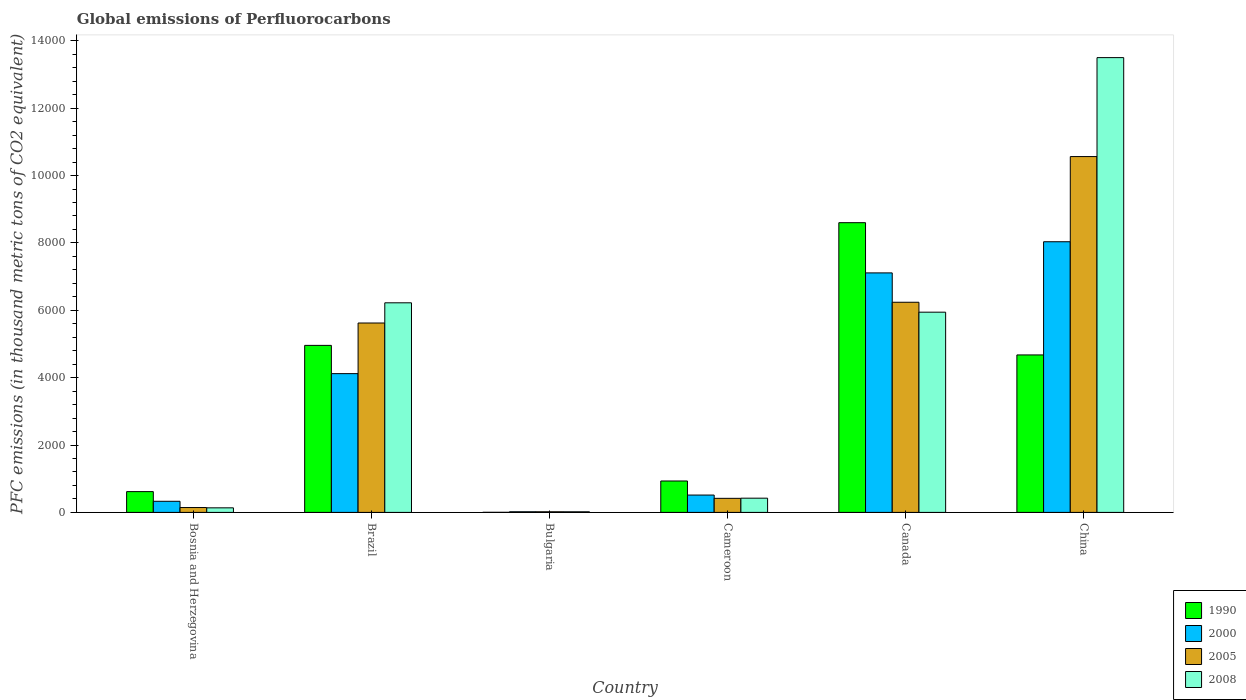Are the number of bars per tick equal to the number of legend labels?
Your answer should be very brief. Yes. Are the number of bars on each tick of the X-axis equal?
Your response must be concise. Yes. What is the label of the 4th group of bars from the left?
Your answer should be very brief. Cameroon. In how many cases, is the number of bars for a given country not equal to the number of legend labels?
Your answer should be compact. 0. What is the global emissions of Perfluorocarbons in 1990 in Bulgaria?
Give a very brief answer. 2.2. Across all countries, what is the maximum global emissions of Perfluorocarbons in 2000?
Make the answer very short. 8034.4. In which country was the global emissions of Perfluorocarbons in 2005 maximum?
Your response must be concise. China. In which country was the global emissions of Perfluorocarbons in 2005 minimum?
Your response must be concise. Bulgaria. What is the total global emissions of Perfluorocarbons in 2005 in the graph?
Make the answer very short. 2.30e+04. What is the difference between the global emissions of Perfluorocarbons in 2008 in Brazil and that in Bulgaria?
Your response must be concise. 6203.6. What is the difference between the global emissions of Perfluorocarbons in 2000 in China and the global emissions of Perfluorocarbons in 2005 in Bosnia and Herzegovina?
Keep it short and to the point. 7890. What is the average global emissions of Perfluorocarbons in 1990 per country?
Offer a terse response. 3297.35. What is the difference between the global emissions of Perfluorocarbons of/in 2005 and global emissions of Perfluorocarbons of/in 1990 in Bosnia and Herzegovina?
Make the answer very short. -472.3. In how many countries, is the global emissions of Perfluorocarbons in 2008 greater than 5200 thousand metric tons?
Provide a short and direct response. 3. What is the ratio of the global emissions of Perfluorocarbons in 2005 in Bulgaria to that in Canada?
Provide a succinct answer. 0. Is the difference between the global emissions of Perfluorocarbons in 2005 in Bosnia and Herzegovina and China greater than the difference between the global emissions of Perfluorocarbons in 1990 in Bosnia and Herzegovina and China?
Keep it short and to the point. No. What is the difference between the highest and the second highest global emissions of Perfluorocarbons in 2005?
Give a very brief answer. 4940.7. What is the difference between the highest and the lowest global emissions of Perfluorocarbons in 1990?
Keep it short and to the point. 8598.1. In how many countries, is the global emissions of Perfluorocarbons in 2005 greater than the average global emissions of Perfluorocarbons in 2005 taken over all countries?
Offer a very short reply. 3. Is it the case that in every country, the sum of the global emissions of Perfluorocarbons in 2008 and global emissions of Perfluorocarbons in 2005 is greater than the sum of global emissions of Perfluorocarbons in 1990 and global emissions of Perfluorocarbons in 2000?
Your response must be concise. No. What does the 1st bar from the right in Cameroon represents?
Keep it short and to the point. 2008. How many bars are there?
Offer a terse response. 24. Are all the bars in the graph horizontal?
Offer a very short reply. No. What is the difference between two consecutive major ticks on the Y-axis?
Your answer should be very brief. 2000. Are the values on the major ticks of Y-axis written in scientific E-notation?
Your answer should be very brief. No. Does the graph contain any zero values?
Your answer should be compact. No. Where does the legend appear in the graph?
Offer a very short reply. Bottom right. How are the legend labels stacked?
Offer a terse response. Vertical. What is the title of the graph?
Give a very brief answer. Global emissions of Perfluorocarbons. What is the label or title of the Y-axis?
Offer a terse response. PFC emissions (in thousand metric tons of CO2 equivalent). What is the PFC emissions (in thousand metric tons of CO2 equivalent) in 1990 in Bosnia and Herzegovina?
Your answer should be compact. 616.7. What is the PFC emissions (in thousand metric tons of CO2 equivalent) of 2000 in Bosnia and Herzegovina?
Provide a succinct answer. 329.9. What is the PFC emissions (in thousand metric tons of CO2 equivalent) of 2005 in Bosnia and Herzegovina?
Your answer should be compact. 144.4. What is the PFC emissions (in thousand metric tons of CO2 equivalent) in 2008 in Bosnia and Herzegovina?
Keep it short and to the point. 135.6. What is the PFC emissions (in thousand metric tons of CO2 equivalent) of 1990 in Brazil?
Ensure brevity in your answer.  4958.1. What is the PFC emissions (in thousand metric tons of CO2 equivalent) in 2000 in Brazil?
Ensure brevity in your answer.  4119.1. What is the PFC emissions (in thousand metric tons of CO2 equivalent) in 2005 in Brazil?
Your answer should be compact. 5622.1. What is the PFC emissions (in thousand metric tons of CO2 equivalent) of 2008 in Brazil?
Provide a succinct answer. 6221.8. What is the PFC emissions (in thousand metric tons of CO2 equivalent) of 1990 in Bulgaria?
Your answer should be compact. 2.2. What is the PFC emissions (in thousand metric tons of CO2 equivalent) in 2008 in Bulgaria?
Provide a short and direct response. 18.2. What is the PFC emissions (in thousand metric tons of CO2 equivalent) in 1990 in Cameroon?
Your answer should be compact. 932.3. What is the PFC emissions (in thousand metric tons of CO2 equivalent) in 2000 in Cameroon?
Make the answer very short. 514.7. What is the PFC emissions (in thousand metric tons of CO2 equivalent) in 2005 in Cameroon?
Offer a very short reply. 417.5. What is the PFC emissions (in thousand metric tons of CO2 equivalent) of 2008 in Cameroon?
Keep it short and to the point. 422.1. What is the PFC emissions (in thousand metric tons of CO2 equivalent) of 1990 in Canada?
Provide a succinct answer. 8600.3. What is the PFC emissions (in thousand metric tons of CO2 equivalent) of 2000 in Canada?
Provide a succinct answer. 7109.9. What is the PFC emissions (in thousand metric tons of CO2 equivalent) of 2005 in Canada?
Make the answer very short. 6238. What is the PFC emissions (in thousand metric tons of CO2 equivalent) of 2008 in Canada?
Provide a succinct answer. 5943.7. What is the PFC emissions (in thousand metric tons of CO2 equivalent) of 1990 in China?
Your answer should be very brief. 4674.5. What is the PFC emissions (in thousand metric tons of CO2 equivalent) of 2000 in China?
Give a very brief answer. 8034.4. What is the PFC emissions (in thousand metric tons of CO2 equivalent) of 2005 in China?
Your response must be concise. 1.06e+04. What is the PFC emissions (in thousand metric tons of CO2 equivalent) in 2008 in China?
Provide a succinct answer. 1.35e+04. Across all countries, what is the maximum PFC emissions (in thousand metric tons of CO2 equivalent) in 1990?
Your response must be concise. 8600.3. Across all countries, what is the maximum PFC emissions (in thousand metric tons of CO2 equivalent) of 2000?
Give a very brief answer. 8034.4. Across all countries, what is the maximum PFC emissions (in thousand metric tons of CO2 equivalent) of 2005?
Your answer should be very brief. 1.06e+04. Across all countries, what is the maximum PFC emissions (in thousand metric tons of CO2 equivalent) in 2008?
Give a very brief answer. 1.35e+04. Across all countries, what is the minimum PFC emissions (in thousand metric tons of CO2 equivalent) in 1990?
Ensure brevity in your answer.  2.2. Across all countries, what is the minimum PFC emissions (in thousand metric tons of CO2 equivalent) in 2008?
Your answer should be very brief. 18.2. What is the total PFC emissions (in thousand metric tons of CO2 equivalent) in 1990 in the graph?
Your answer should be compact. 1.98e+04. What is the total PFC emissions (in thousand metric tons of CO2 equivalent) in 2000 in the graph?
Make the answer very short. 2.01e+04. What is the total PFC emissions (in thousand metric tons of CO2 equivalent) in 2005 in the graph?
Your answer should be very brief. 2.30e+04. What is the total PFC emissions (in thousand metric tons of CO2 equivalent) of 2008 in the graph?
Give a very brief answer. 2.62e+04. What is the difference between the PFC emissions (in thousand metric tons of CO2 equivalent) in 1990 in Bosnia and Herzegovina and that in Brazil?
Ensure brevity in your answer.  -4341.4. What is the difference between the PFC emissions (in thousand metric tons of CO2 equivalent) of 2000 in Bosnia and Herzegovina and that in Brazil?
Your answer should be compact. -3789.2. What is the difference between the PFC emissions (in thousand metric tons of CO2 equivalent) of 2005 in Bosnia and Herzegovina and that in Brazil?
Ensure brevity in your answer.  -5477.7. What is the difference between the PFC emissions (in thousand metric tons of CO2 equivalent) of 2008 in Bosnia and Herzegovina and that in Brazil?
Your response must be concise. -6086.2. What is the difference between the PFC emissions (in thousand metric tons of CO2 equivalent) in 1990 in Bosnia and Herzegovina and that in Bulgaria?
Ensure brevity in your answer.  614.5. What is the difference between the PFC emissions (in thousand metric tons of CO2 equivalent) of 2000 in Bosnia and Herzegovina and that in Bulgaria?
Your answer should be compact. 310.8. What is the difference between the PFC emissions (in thousand metric tons of CO2 equivalent) in 2005 in Bosnia and Herzegovina and that in Bulgaria?
Give a very brief answer. 125.9. What is the difference between the PFC emissions (in thousand metric tons of CO2 equivalent) of 2008 in Bosnia and Herzegovina and that in Bulgaria?
Provide a succinct answer. 117.4. What is the difference between the PFC emissions (in thousand metric tons of CO2 equivalent) in 1990 in Bosnia and Herzegovina and that in Cameroon?
Keep it short and to the point. -315.6. What is the difference between the PFC emissions (in thousand metric tons of CO2 equivalent) of 2000 in Bosnia and Herzegovina and that in Cameroon?
Offer a terse response. -184.8. What is the difference between the PFC emissions (in thousand metric tons of CO2 equivalent) of 2005 in Bosnia and Herzegovina and that in Cameroon?
Provide a succinct answer. -273.1. What is the difference between the PFC emissions (in thousand metric tons of CO2 equivalent) in 2008 in Bosnia and Herzegovina and that in Cameroon?
Provide a succinct answer. -286.5. What is the difference between the PFC emissions (in thousand metric tons of CO2 equivalent) of 1990 in Bosnia and Herzegovina and that in Canada?
Give a very brief answer. -7983.6. What is the difference between the PFC emissions (in thousand metric tons of CO2 equivalent) of 2000 in Bosnia and Herzegovina and that in Canada?
Offer a very short reply. -6780. What is the difference between the PFC emissions (in thousand metric tons of CO2 equivalent) in 2005 in Bosnia and Herzegovina and that in Canada?
Ensure brevity in your answer.  -6093.6. What is the difference between the PFC emissions (in thousand metric tons of CO2 equivalent) in 2008 in Bosnia and Herzegovina and that in Canada?
Ensure brevity in your answer.  -5808.1. What is the difference between the PFC emissions (in thousand metric tons of CO2 equivalent) of 1990 in Bosnia and Herzegovina and that in China?
Offer a terse response. -4057.8. What is the difference between the PFC emissions (in thousand metric tons of CO2 equivalent) in 2000 in Bosnia and Herzegovina and that in China?
Offer a very short reply. -7704.5. What is the difference between the PFC emissions (in thousand metric tons of CO2 equivalent) in 2005 in Bosnia and Herzegovina and that in China?
Give a very brief answer. -1.04e+04. What is the difference between the PFC emissions (in thousand metric tons of CO2 equivalent) in 2008 in Bosnia and Herzegovina and that in China?
Make the answer very short. -1.34e+04. What is the difference between the PFC emissions (in thousand metric tons of CO2 equivalent) of 1990 in Brazil and that in Bulgaria?
Your response must be concise. 4955.9. What is the difference between the PFC emissions (in thousand metric tons of CO2 equivalent) in 2000 in Brazil and that in Bulgaria?
Give a very brief answer. 4100. What is the difference between the PFC emissions (in thousand metric tons of CO2 equivalent) in 2005 in Brazil and that in Bulgaria?
Offer a very short reply. 5603.6. What is the difference between the PFC emissions (in thousand metric tons of CO2 equivalent) of 2008 in Brazil and that in Bulgaria?
Provide a succinct answer. 6203.6. What is the difference between the PFC emissions (in thousand metric tons of CO2 equivalent) in 1990 in Brazil and that in Cameroon?
Offer a very short reply. 4025.8. What is the difference between the PFC emissions (in thousand metric tons of CO2 equivalent) of 2000 in Brazil and that in Cameroon?
Your answer should be very brief. 3604.4. What is the difference between the PFC emissions (in thousand metric tons of CO2 equivalent) of 2005 in Brazil and that in Cameroon?
Your answer should be compact. 5204.6. What is the difference between the PFC emissions (in thousand metric tons of CO2 equivalent) of 2008 in Brazil and that in Cameroon?
Ensure brevity in your answer.  5799.7. What is the difference between the PFC emissions (in thousand metric tons of CO2 equivalent) of 1990 in Brazil and that in Canada?
Offer a terse response. -3642.2. What is the difference between the PFC emissions (in thousand metric tons of CO2 equivalent) of 2000 in Brazil and that in Canada?
Your response must be concise. -2990.8. What is the difference between the PFC emissions (in thousand metric tons of CO2 equivalent) of 2005 in Brazil and that in Canada?
Ensure brevity in your answer.  -615.9. What is the difference between the PFC emissions (in thousand metric tons of CO2 equivalent) of 2008 in Brazil and that in Canada?
Provide a short and direct response. 278.1. What is the difference between the PFC emissions (in thousand metric tons of CO2 equivalent) in 1990 in Brazil and that in China?
Offer a very short reply. 283.6. What is the difference between the PFC emissions (in thousand metric tons of CO2 equivalent) of 2000 in Brazil and that in China?
Your response must be concise. -3915.3. What is the difference between the PFC emissions (in thousand metric tons of CO2 equivalent) of 2005 in Brazil and that in China?
Provide a succinct answer. -4940.7. What is the difference between the PFC emissions (in thousand metric tons of CO2 equivalent) of 2008 in Brazil and that in China?
Your answer should be compact. -7278.8. What is the difference between the PFC emissions (in thousand metric tons of CO2 equivalent) in 1990 in Bulgaria and that in Cameroon?
Keep it short and to the point. -930.1. What is the difference between the PFC emissions (in thousand metric tons of CO2 equivalent) of 2000 in Bulgaria and that in Cameroon?
Provide a short and direct response. -495.6. What is the difference between the PFC emissions (in thousand metric tons of CO2 equivalent) of 2005 in Bulgaria and that in Cameroon?
Make the answer very short. -399. What is the difference between the PFC emissions (in thousand metric tons of CO2 equivalent) in 2008 in Bulgaria and that in Cameroon?
Your response must be concise. -403.9. What is the difference between the PFC emissions (in thousand metric tons of CO2 equivalent) in 1990 in Bulgaria and that in Canada?
Provide a short and direct response. -8598.1. What is the difference between the PFC emissions (in thousand metric tons of CO2 equivalent) of 2000 in Bulgaria and that in Canada?
Provide a succinct answer. -7090.8. What is the difference between the PFC emissions (in thousand metric tons of CO2 equivalent) in 2005 in Bulgaria and that in Canada?
Give a very brief answer. -6219.5. What is the difference between the PFC emissions (in thousand metric tons of CO2 equivalent) of 2008 in Bulgaria and that in Canada?
Ensure brevity in your answer.  -5925.5. What is the difference between the PFC emissions (in thousand metric tons of CO2 equivalent) in 1990 in Bulgaria and that in China?
Your answer should be compact. -4672.3. What is the difference between the PFC emissions (in thousand metric tons of CO2 equivalent) of 2000 in Bulgaria and that in China?
Provide a short and direct response. -8015.3. What is the difference between the PFC emissions (in thousand metric tons of CO2 equivalent) in 2005 in Bulgaria and that in China?
Ensure brevity in your answer.  -1.05e+04. What is the difference between the PFC emissions (in thousand metric tons of CO2 equivalent) of 2008 in Bulgaria and that in China?
Offer a very short reply. -1.35e+04. What is the difference between the PFC emissions (in thousand metric tons of CO2 equivalent) in 1990 in Cameroon and that in Canada?
Your answer should be compact. -7668. What is the difference between the PFC emissions (in thousand metric tons of CO2 equivalent) of 2000 in Cameroon and that in Canada?
Offer a terse response. -6595.2. What is the difference between the PFC emissions (in thousand metric tons of CO2 equivalent) in 2005 in Cameroon and that in Canada?
Your response must be concise. -5820.5. What is the difference between the PFC emissions (in thousand metric tons of CO2 equivalent) of 2008 in Cameroon and that in Canada?
Offer a very short reply. -5521.6. What is the difference between the PFC emissions (in thousand metric tons of CO2 equivalent) in 1990 in Cameroon and that in China?
Offer a very short reply. -3742.2. What is the difference between the PFC emissions (in thousand metric tons of CO2 equivalent) of 2000 in Cameroon and that in China?
Your response must be concise. -7519.7. What is the difference between the PFC emissions (in thousand metric tons of CO2 equivalent) of 2005 in Cameroon and that in China?
Your response must be concise. -1.01e+04. What is the difference between the PFC emissions (in thousand metric tons of CO2 equivalent) in 2008 in Cameroon and that in China?
Your response must be concise. -1.31e+04. What is the difference between the PFC emissions (in thousand metric tons of CO2 equivalent) of 1990 in Canada and that in China?
Ensure brevity in your answer.  3925.8. What is the difference between the PFC emissions (in thousand metric tons of CO2 equivalent) in 2000 in Canada and that in China?
Keep it short and to the point. -924.5. What is the difference between the PFC emissions (in thousand metric tons of CO2 equivalent) of 2005 in Canada and that in China?
Ensure brevity in your answer.  -4324.8. What is the difference between the PFC emissions (in thousand metric tons of CO2 equivalent) in 2008 in Canada and that in China?
Your answer should be compact. -7556.9. What is the difference between the PFC emissions (in thousand metric tons of CO2 equivalent) of 1990 in Bosnia and Herzegovina and the PFC emissions (in thousand metric tons of CO2 equivalent) of 2000 in Brazil?
Make the answer very short. -3502.4. What is the difference between the PFC emissions (in thousand metric tons of CO2 equivalent) in 1990 in Bosnia and Herzegovina and the PFC emissions (in thousand metric tons of CO2 equivalent) in 2005 in Brazil?
Provide a succinct answer. -5005.4. What is the difference between the PFC emissions (in thousand metric tons of CO2 equivalent) in 1990 in Bosnia and Herzegovina and the PFC emissions (in thousand metric tons of CO2 equivalent) in 2008 in Brazil?
Provide a short and direct response. -5605.1. What is the difference between the PFC emissions (in thousand metric tons of CO2 equivalent) in 2000 in Bosnia and Herzegovina and the PFC emissions (in thousand metric tons of CO2 equivalent) in 2005 in Brazil?
Your answer should be very brief. -5292.2. What is the difference between the PFC emissions (in thousand metric tons of CO2 equivalent) of 2000 in Bosnia and Herzegovina and the PFC emissions (in thousand metric tons of CO2 equivalent) of 2008 in Brazil?
Ensure brevity in your answer.  -5891.9. What is the difference between the PFC emissions (in thousand metric tons of CO2 equivalent) of 2005 in Bosnia and Herzegovina and the PFC emissions (in thousand metric tons of CO2 equivalent) of 2008 in Brazil?
Ensure brevity in your answer.  -6077.4. What is the difference between the PFC emissions (in thousand metric tons of CO2 equivalent) in 1990 in Bosnia and Herzegovina and the PFC emissions (in thousand metric tons of CO2 equivalent) in 2000 in Bulgaria?
Your answer should be compact. 597.6. What is the difference between the PFC emissions (in thousand metric tons of CO2 equivalent) of 1990 in Bosnia and Herzegovina and the PFC emissions (in thousand metric tons of CO2 equivalent) of 2005 in Bulgaria?
Make the answer very short. 598.2. What is the difference between the PFC emissions (in thousand metric tons of CO2 equivalent) of 1990 in Bosnia and Herzegovina and the PFC emissions (in thousand metric tons of CO2 equivalent) of 2008 in Bulgaria?
Offer a very short reply. 598.5. What is the difference between the PFC emissions (in thousand metric tons of CO2 equivalent) of 2000 in Bosnia and Herzegovina and the PFC emissions (in thousand metric tons of CO2 equivalent) of 2005 in Bulgaria?
Your response must be concise. 311.4. What is the difference between the PFC emissions (in thousand metric tons of CO2 equivalent) in 2000 in Bosnia and Herzegovina and the PFC emissions (in thousand metric tons of CO2 equivalent) in 2008 in Bulgaria?
Give a very brief answer. 311.7. What is the difference between the PFC emissions (in thousand metric tons of CO2 equivalent) in 2005 in Bosnia and Herzegovina and the PFC emissions (in thousand metric tons of CO2 equivalent) in 2008 in Bulgaria?
Provide a short and direct response. 126.2. What is the difference between the PFC emissions (in thousand metric tons of CO2 equivalent) in 1990 in Bosnia and Herzegovina and the PFC emissions (in thousand metric tons of CO2 equivalent) in 2000 in Cameroon?
Make the answer very short. 102. What is the difference between the PFC emissions (in thousand metric tons of CO2 equivalent) of 1990 in Bosnia and Herzegovina and the PFC emissions (in thousand metric tons of CO2 equivalent) of 2005 in Cameroon?
Offer a very short reply. 199.2. What is the difference between the PFC emissions (in thousand metric tons of CO2 equivalent) in 1990 in Bosnia and Herzegovina and the PFC emissions (in thousand metric tons of CO2 equivalent) in 2008 in Cameroon?
Ensure brevity in your answer.  194.6. What is the difference between the PFC emissions (in thousand metric tons of CO2 equivalent) in 2000 in Bosnia and Herzegovina and the PFC emissions (in thousand metric tons of CO2 equivalent) in 2005 in Cameroon?
Offer a very short reply. -87.6. What is the difference between the PFC emissions (in thousand metric tons of CO2 equivalent) of 2000 in Bosnia and Herzegovina and the PFC emissions (in thousand metric tons of CO2 equivalent) of 2008 in Cameroon?
Make the answer very short. -92.2. What is the difference between the PFC emissions (in thousand metric tons of CO2 equivalent) in 2005 in Bosnia and Herzegovina and the PFC emissions (in thousand metric tons of CO2 equivalent) in 2008 in Cameroon?
Give a very brief answer. -277.7. What is the difference between the PFC emissions (in thousand metric tons of CO2 equivalent) in 1990 in Bosnia and Herzegovina and the PFC emissions (in thousand metric tons of CO2 equivalent) in 2000 in Canada?
Make the answer very short. -6493.2. What is the difference between the PFC emissions (in thousand metric tons of CO2 equivalent) in 1990 in Bosnia and Herzegovina and the PFC emissions (in thousand metric tons of CO2 equivalent) in 2005 in Canada?
Give a very brief answer. -5621.3. What is the difference between the PFC emissions (in thousand metric tons of CO2 equivalent) of 1990 in Bosnia and Herzegovina and the PFC emissions (in thousand metric tons of CO2 equivalent) of 2008 in Canada?
Ensure brevity in your answer.  -5327. What is the difference between the PFC emissions (in thousand metric tons of CO2 equivalent) in 2000 in Bosnia and Herzegovina and the PFC emissions (in thousand metric tons of CO2 equivalent) in 2005 in Canada?
Provide a short and direct response. -5908.1. What is the difference between the PFC emissions (in thousand metric tons of CO2 equivalent) in 2000 in Bosnia and Herzegovina and the PFC emissions (in thousand metric tons of CO2 equivalent) in 2008 in Canada?
Your answer should be very brief. -5613.8. What is the difference between the PFC emissions (in thousand metric tons of CO2 equivalent) in 2005 in Bosnia and Herzegovina and the PFC emissions (in thousand metric tons of CO2 equivalent) in 2008 in Canada?
Provide a short and direct response. -5799.3. What is the difference between the PFC emissions (in thousand metric tons of CO2 equivalent) in 1990 in Bosnia and Herzegovina and the PFC emissions (in thousand metric tons of CO2 equivalent) in 2000 in China?
Provide a succinct answer. -7417.7. What is the difference between the PFC emissions (in thousand metric tons of CO2 equivalent) in 1990 in Bosnia and Herzegovina and the PFC emissions (in thousand metric tons of CO2 equivalent) in 2005 in China?
Make the answer very short. -9946.1. What is the difference between the PFC emissions (in thousand metric tons of CO2 equivalent) in 1990 in Bosnia and Herzegovina and the PFC emissions (in thousand metric tons of CO2 equivalent) in 2008 in China?
Your answer should be compact. -1.29e+04. What is the difference between the PFC emissions (in thousand metric tons of CO2 equivalent) in 2000 in Bosnia and Herzegovina and the PFC emissions (in thousand metric tons of CO2 equivalent) in 2005 in China?
Give a very brief answer. -1.02e+04. What is the difference between the PFC emissions (in thousand metric tons of CO2 equivalent) in 2000 in Bosnia and Herzegovina and the PFC emissions (in thousand metric tons of CO2 equivalent) in 2008 in China?
Provide a succinct answer. -1.32e+04. What is the difference between the PFC emissions (in thousand metric tons of CO2 equivalent) of 2005 in Bosnia and Herzegovina and the PFC emissions (in thousand metric tons of CO2 equivalent) of 2008 in China?
Keep it short and to the point. -1.34e+04. What is the difference between the PFC emissions (in thousand metric tons of CO2 equivalent) in 1990 in Brazil and the PFC emissions (in thousand metric tons of CO2 equivalent) in 2000 in Bulgaria?
Ensure brevity in your answer.  4939. What is the difference between the PFC emissions (in thousand metric tons of CO2 equivalent) in 1990 in Brazil and the PFC emissions (in thousand metric tons of CO2 equivalent) in 2005 in Bulgaria?
Your response must be concise. 4939.6. What is the difference between the PFC emissions (in thousand metric tons of CO2 equivalent) in 1990 in Brazil and the PFC emissions (in thousand metric tons of CO2 equivalent) in 2008 in Bulgaria?
Ensure brevity in your answer.  4939.9. What is the difference between the PFC emissions (in thousand metric tons of CO2 equivalent) of 2000 in Brazil and the PFC emissions (in thousand metric tons of CO2 equivalent) of 2005 in Bulgaria?
Your response must be concise. 4100.6. What is the difference between the PFC emissions (in thousand metric tons of CO2 equivalent) of 2000 in Brazil and the PFC emissions (in thousand metric tons of CO2 equivalent) of 2008 in Bulgaria?
Offer a very short reply. 4100.9. What is the difference between the PFC emissions (in thousand metric tons of CO2 equivalent) in 2005 in Brazil and the PFC emissions (in thousand metric tons of CO2 equivalent) in 2008 in Bulgaria?
Keep it short and to the point. 5603.9. What is the difference between the PFC emissions (in thousand metric tons of CO2 equivalent) in 1990 in Brazil and the PFC emissions (in thousand metric tons of CO2 equivalent) in 2000 in Cameroon?
Offer a very short reply. 4443.4. What is the difference between the PFC emissions (in thousand metric tons of CO2 equivalent) in 1990 in Brazil and the PFC emissions (in thousand metric tons of CO2 equivalent) in 2005 in Cameroon?
Your response must be concise. 4540.6. What is the difference between the PFC emissions (in thousand metric tons of CO2 equivalent) in 1990 in Brazil and the PFC emissions (in thousand metric tons of CO2 equivalent) in 2008 in Cameroon?
Your answer should be compact. 4536. What is the difference between the PFC emissions (in thousand metric tons of CO2 equivalent) in 2000 in Brazil and the PFC emissions (in thousand metric tons of CO2 equivalent) in 2005 in Cameroon?
Provide a succinct answer. 3701.6. What is the difference between the PFC emissions (in thousand metric tons of CO2 equivalent) in 2000 in Brazil and the PFC emissions (in thousand metric tons of CO2 equivalent) in 2008 in Cameroon?
Give a very brief answer. 3697. What is the difference between the PFC emissions (in thousand metric tons of CO2 equivalent) in 2005 in Brazil and the PFC emissions (in thousand metric tons of CO2 equivalent) in 2008 in Cameroon?
Provide a succinct answer. 5200. What is the difference between the PFC emissions (in thousand metric tons of CO2 equivalent) in 1990 in Brazil and the PFC emissions (in thousand metric tons of CO2 equivalent) in 2000 in Canada?
Provide a short and direct response. -2151.8. What is the difference between the PFC emissions (in thousand metric tons of CO2 equivalent) in 1990 in Brazil and the PFC emissions (in thousand metric tons of CO2 equivalent) in 2005 in Canada?
Provide a succinct answer. -1279.9. What is the difference between the PFC emissions (in thousand metric tons of CO2 equivalent) in 1990 in Brazil and the PFC emissions (in thousand metric tons of CO2 equivalent) in 2008 in Canada?
Provide a short and direct response. -985.6. What is the difference between the PFC emissions (in thousand metric tons of CO2 equivalent) in 2000 in Brazil and the PFC emissions (in thousand metric tons of CO2 equivalent) in 2005 in Canada?
Offer a terse response. -2118.9. What is the difference between the PFC emissions (in thousand metric tons of CO2 equivalent) of 2000 in Brazil and the PFC emissions (in thousand metric tons of CO2 equivalent) of 2008 in Canada?
Provide a short and direct response. -1824.6. What is the difference between the PFC emissions (in thousand metric tons of CO2 equivalent) in 2005 in Brazil and the PFC emissions (in thousand metric tons of CO2 equivalent) in 2008 in Canada?
Give a very brief answer. -321.6. What is the difference between the PFC emissions (in thousand metric tons of CO2 equivalent) of 1990 in Brazil and the PFC emissions (in thousand metric tons of CO2 equivalent) of 2000 in China?
Give a very brief answer. -3076.3. What is the difference between the PFC emissions (in thousand metric tons of CO2 equivalent) of 1990 in Brazil and the PFC emissions (in thousand metric tons of CO2 equivalent) of 2005 in China?
Offer a terse response. -5604.7. What is the difference between the PFC emissions (in thousand metric tons of CO2 equivalent) in 1990 in Brazil and the PFC emissions (in thousand metric tons of CO2 equivalent) in 2008 in China?
Your response must be concise. -8542.5. What is the difference between the PFC emissions (in thousand metric tons of CO2 equivalent) of 2000 in Brazil and the PFC emissions (in thousand metric tons of CO2 equivalent) of 2005 in China?
Your response must be concise. -6443.7. What is the difference between the PFC emissions (in thousand metric tons of CO2 equivalent) of 2000 in Brazil and the PFC emissions (in thousand metric tons of CO2 equivalent) of 2008 in China?
Your response must be concise. -9381.5. What is the difference between the PFC emissions (in thousand metric tons of CO2 equivalent) in 2005 in Brazil and the PFC emissions (in thousand metric tons of CO2 equivalent) in 2008 in China?
Ensure brevity in your answer.  -7878.5. What is the difference between the PFC emissions (in thousand metric tons of CO2 equivalent) of 1990 in Bulgaria and the PFC emissions (in thousand metric tons of CO2 equivalent) of 2000 in Cameroon?
Your answer should be very brief. -512.5. What is the difference between the PFC emissions (in thousand metric tons of CO2 equivalent) in 1990 in Bulgaria and the PFC emissions (in thousand metric tons of CO2 equivalent) in 2005 in Cameroon?
Your answer should be very brief. -415.3. What is the difference between the PFC emissions (in thousand metric tons of CO2 equivalent) in 1990 in Bulgaria and the PFC emissions (in thousand metric tons of CO2 equivalent) in 2008 in Cameroon?
Provide a short and direct response. -419.9. What is the difference between the PFC emissions (in thousand metric tons of CO2 equivalent) of 2000 in Bulgaria and the PFC emissions (in thousand metric tons of CO2 equivalent) of 2005 in Cameroon?
Give a very brief answer. -398.4. What is the difference between the PFC emissions (in thousand metric tons of CO2 equivalent) of 2000 in Bulgaria and the PFC emissions (in thousand metric tons of CO2 equivalent) of 2008 in Cameroon?
Offer a terse response. -403. What is the difference between the PFC emissions (in thousand metric tons of CO2 equivalent) of 2005 in Bulgaria and the PFC emissions (in thousand metric tons of CO2 equivalent) of 2008 in Cameroon?
Offer a terse response. -403.6. What is the difference between the PFC emissions (in thousand metric tons of CO2 equivalent) of 1990 in Bulgaria and the PFC emissions (in thousand metric tons of CO2 equivalent) of 2000 in Canada?
Keep it short and to the point. -7107.7. What is the difference between the PFC emissions (in thousand metric tons of CO2 equivalent) of 1990 in Bulgaria and the PFC emissions (in thousand metric tons of CO2 equivalent) of 2005 in Canada?
Keep it short and to the point. -6235.8. What is the difference between the PFC emissions (in thousand metric tons of CO2 equivalent) in 1990 in Bulgaria and the PFC emissions (in thousand metric tons of CO2 equivalent) in 2008 in Canada?
Keep it short and to the point. -5941.5. What is the difference between the PFC emissions (in thousand metric tons of CO2 equivalent) in 2000 in Bulgaria and the PFC emissions (in thousand metric tons of CO2 equivalent) in 2005 in Canada?
Give a very brief answer. -6218.9. What is the difference between the PFC emissions (in thousand metric tons of CO2 equivalent) of 2000 in Bulgaria and the PFC emissions (in thousand metric tons of CO2 equivalent) of 2008 in Canada?
Offer a terse response. -5924.6. What is the difference between the PFC emissions (in thousand metric tons of CO2 equivalent) of 2005 in Bulgaria and the PFC emissions (in thousand metric tons of CO2 equivalent) of 2008 in Canada?
Your answer should be compact. -5925.2. What is the difference between the PFC emissions (in thousand metric tons of CO2 equivalent) in 1990 in Bulgaria and the PFC emissions (in thousand metric tons of CO2 equivalent) in 2000 in China?
Give a very brief answer. -8032.2. What is the difference between the PFC emissions (in thousand metric tons of CO2 equivalent) in 1990 in Bulgaria and the PFC emissions (in thousand metric tons of CO2 equivalent) in 2005 in China?
Provide a short and direct response. -1.06e+04. What is the difference between the PFC emissions (in thousand metric tons of CO2 equivalent) in 1990 in Bulgaria and the PFC emissions (in thousand metric tons of CO2 equivalent) in 2008 in China?
Give a very brief answer. -1.35e+04. What is the difference between the PFC emissions (in thousand metric tons of CO2 equivalent) of 2000 in Bulgaria and the PFC emissions (in thousand metric tons of CO2 equivalent) of 2005 in China?
Provide a succinct answer. -1.05e+04. What is the difference between the PFC emissions (in thousand metric tons of CO2 equivalent) in 2000 in Bulgaria and the PFC emissions (in thousand metric tons of CO2 equivalent) in 2008 in China?
Keep it short and to the point. -1.35e+04. What is the difference between the PFC emissions (in thousand metric tons of CO2 equivalent) in 2005 in Bulgaria and the PFC emissions (in thousand metric tons of CO2 equivalent) in 2008 in China?
Make the answer very short. -1.35e+04. What is the difference between the PFC emissions (in thousand metric tons of CO2 equivalent) of 1990 in Cameroon and the PFC emissions (in thousand metric tons of CO2 equivalent) of 2000 in Canada?
Your response must be concise. -6177.6. What is the difference between the PFC emissions (in thousand metric tons of CO2 equivalent) of 1990 in Cameroon and the PFC emissions (in thousand metric tons of CO2 equivalent) of 2005 in Canada?
Make the answer very short. -5305.7. What is the difference between the PFC emissions (in thousand metric tons of CO2 equivalent) in 1990 in Cameroon and the PFC emissions (in thousand metric tons of CO2 equivalent) in 2008 in Canada?
Provide a short and direct response. -5011.4. What is the difference between the PFC emissions (in thousand metric tons of CO2 equivalent) of 2000 in Cameroon and the PFC emissions (in thousand metric tons of CO2 equivalent) of 2005 in Canada?
Your answer should be very brief. -5723.3. What is the difference between the PFC emissions (in thousand metric tons of CO2 equivalent) in 2000 in Cameroon and the PFC emissions (in thousand metric tons of CO2 equivalent) in 2008 in Canada?
Provide a short and direct response. -5429. What is the difference between the PFC emissions (in thousand metric tons of CO2 equivalent) of 2005 in Cameroon and the PFC emissions (in thousand metric tons of CO2 equivalent) of 2008 in Canada?
Make the answer very short. -5526.2. What is the difference between the PFC emissions (in thousand metric tons of CO2 equivalent) of 1990 in Cameroon and the PFC emissions (in thousand metric tons of CO2 equivalent) of 2000 in China?
Offer a terse response. -7102.1. What is the difference between the PFC emissions (in thousand metric tons of CO2 equivalent) of 1990 in Cameroon and the PFC emissions (in thousand metric tons of CO2 equivalent) of 2005 in China?
Provide a short and direct response. -9630.5. What is the difference between the PFC emissions (in thousand metric tons of CO2 equivalent) in 1990 in Cameroon and the PFC emissions (in thousand metric tons of CO2 equivalent) in 2008 in China?
Make the answer very short. -1.26e+04. What is the difference between the PFC emissions (in thousand metric tons of CO2 equivalent) in 2000 in Cameroon and the PFC emissions (in thousand metric tons of CO2 equivalent) in 2005 in China?
Make the answer very short. -1.00e+04. What is the difference between the PFC emissions (in thousand metric tons of CO2 equivalent) in 2000 in Cameroon and the PFC emissions (in thousand metric tons of CO2 equivalent) in 2008 in China?
Your answer should be compact. -1.30e+04. What is the difference between the PFC emissions (in thousand metric tons of CO2 equivalent) of 2005 in Cameroon and the PFC emissions (in thousand metric tons of CO2 equivalent) of 2008 in China?
Keep it short and to the point. -1.31e+04. What is the difference between the PFC emissions (in thousand metric tons of CO2 equivalent) of 1990 in Canada and the PFC emissions (in thousand metric tons of CO2 equivalent) of 2000 in China?
Provide a short and direct response. 565.9. What is the difference between the PFC emissions (in thousand metric tons of CO2 equivalent) in 1990 in Canada and the PFC emissions (in thousand metric tons of CO2 equivalent) in 2005 in China?
Ensure brevity in your answer.  -1962.5. What is the difference between the PFC emissions (in thousand metric tons of CO2 equivalent) in 1990 in Canada and the PFC emissions (in thousand metric tons of CO2 equivalent) in 2008 in China?
Offer a very short reply. -4900.3. What is the difference between the PFC emissions (in thousand metric tons of CO2 equivalent) of 2000 in Canada and the PFC emissions (in thousand metric tons of CO2 equivalent) of 2005 in China?
Your response must be concise. -3452.9. What is the difference between the PFC emissions (in thousand metric tons of CO2 equivalent) in 2000 in Canada and the PFC emissions (in thousand metric tons of CO2 equivalent) in 2008 in China?
Provide a short and direct response. -6390.7. What is the difference between the PFC emissions (in thousand metric tons of CO2 equivalent) of 2005 in Canada and the PFC emissions (in thousand metric tons of CO2 equivalent) of 2008 in China?
Your answer should be compact. -7262.6. What is the average PFC emissions (in thousand metric tons of CO2 equivalent) of 1990 per country?
Provide a succinct answer. 3297.35. What is the average PFC emissions (in thousand metric tons of CO2 equivalent) of 2000 per country?
Your answer should be very brief. 3354.52. What is the average PFC emissions (in thousand metric tons of CO2 equivalent) of 2005 per country?
Your answer should be very brief. 3833.88. What is the average PFC emissions (in thousand metric tons of CO2 equivalent) in 2008 per country?
Give a very brief answer. 4373.67. What is the difference between the PFC emissions (in thousand metric tons of CO2 equivalent) in 1990 and PFC emissions (in thousand metric tons of CO2 equivalent) in 2000 in Bosnia and Herzegovina?
Give a very brief answer. 286.8. What is the difference between the PFC emissions (in thousand metric tons of CO2 equivalent) in 1990 and PFC emissions (in thousand metric tons of CO2 equivalent) in 2005 in Bosnia and Herzegovina?
Give a very brief answer. 472.3. What is the difference between the PFC emissions (in thousand metric tons of CO2 equivalent) of 1990 and PFC emissions (in thousand metric tons of CO2 equivalent) of 2008 in Bosnia and Herzegovina?
Ensure brevity in your answer.  481.1. What is the difference between the PFC emissions (in thousand metric tons of CO2 equivalent) in 2000 and PFC emissions (in thousand metric tons of CO2 equivalent) in 2005 in Bosnia and Herzegovina?
Your response must be concise. 185.5. What is the difference between the PFC emissions (in thousand metric tons of CO2 equivalent) in 2000 and PFC emissions (in thousand metric tons of CO2 equivalent) in 2008 in Bosnia and Herzegovina?
Your response must be concise. 194.3. What is the difference between the PFC emissions (in thousand metric tons of CO2 equivalent) of 1990 and PFC emissions (in thousand metric tons of CO2 equivalent) of 2000 in Brazil?
Ensure brevity in your answer.  839. What is the difference between the PFC emissions (in thousand metric tons of CO2 equivalent) of 1990 and PFC emissions (in thousand metric tons of CO2 equivalent) of 2005 in Brazil?
Give a very brief answer. -664. What is the difference between the PFC emissions (in thousand metric tons of CO2 equivalent) in 1990 and PFC emissions (in thousand metric tons of CO2 equivalent) in 2008 in Brazil?
Ensure brevity in your answer.  -1263.7. What is the difference between the PFC emissions (in thousand metric tons of CO2 equivalent) of 2000 and PFC emissions (in thousand metric tons of CO2 equivalent) of 2005 in Brazil?
Make the answer very short. -1503. What is the difference between the PFC emissions (in thousand metric tons of CO2 equivalent) of 2000 and PFC emissions (in thousand metric tons of CO2 equivalent) of 2008 in Brazil?
Your response must be concise. -2102.7. What is the difference between the PFC emissions (in thousand metric tons of CO2 equivalent) in 2005 and PFC emissions (in thousand metric tons of CO2 equivalent) in 2008 in Brazil?
Keep it short and to the point. -599.7. What is the difference between the PFC emissions (in thousand metric tons of CO2 equivalent) of 1990 and PFC emissions (in thousand metric tons of CO2 equivalent) of 2000 in Bulgaria?
Give a very brief answer. -16.9. What is the difference between the PFC emissions (in thousand metric tons of CO2 equivalent) of 1990 and PFC emissions (in thousand metric tons of CO2 equivalent) of 2005 in Bulgaria?
Offer a terse response. -16.3. What is the difference between the PFC emissions (in thousand metric tons of CO2 equivalent) in 2000 and PFC emissions (in thousand metric tons of CO2 equivalent) in 2005 in Bulgaria?
Ensure brevity in your answer.  0.6. What is the difference between the PFC emissions (in thousand metric tons of CO2 equivalent) of 2000 and PFC emissions (in thousand metric tons of CO2 equivalent) of 2008 in Bulgaria?
Offer a very short reply. 0.9. What is the difference between the PFC emissions (in thousand metric tons of CO2 equivalent) in 1990 and PFC emissions (in thousand metric tons of CO2 equivalent) in 2000 in Cameroon?
Your answer should be compact. 417.6. What is the difference between the PFC emissions (in thousand metric tons of CO2 equivalent) of 1990 and PFC emissions (in thousand metric tons of CO2 equivalent) of 2005 in Cameroon?
Your answer should be very brief. 514.8. What is the difference between the PFC emissions (in thousand metric tons of CO2 equivalent) of 1990 and PFC emissions (in thousand metric tons of CO2 equivalent) of 2008 in Cameroon?
Offer a very short reply. 510.2. What is the difference between the PFC emissions (in thousand metric tons of CO2 equivalent) in 2000 and PFC emissions (in thousand metric tons of CO2 equivalent) in 2005 in Cameroon?
Your response must be concise. 97.2. What is the difference between the PFC emissions (in thousand metric tons of CO2 equivalent) in 2000 and PFC emissions (in thousand metric tons of CO2 equivalent) in 2008 in Cameroon?
Make the answer very short. 92.6. What is the difference between the PFC emissions (in thousand metric tons of CO2 equivalent) of 2005 and PFC emissions (in thousand metric tons of CO2 equivalent) of 2008 in Cameroon?
Offer a terse response. -4.6. What is the difference between the PFC emissions (in thousand metric tons of CO2 equivalent) of 1990 and PFC emissions (in thousand metric tons of CO2 equivalent) of 2000 in Canada?
Keep it short and to the point. 1490.4. What is the difference between the PFC emissions (in thousand metric tons of CO2 equivalent) of 1990 and PFC emissions (in thousand metric tons of CO2 equivalent) of 2005 in Canada?
Provide a short and direct response. 2362.3. What is the difference between the PFC emissions (in thousand metric tons of CO2 equivalent) in 1990 and PFC emissions (in thousand metric tons of CO2 equivalent) in 2008 in Canada?
Your response must be concise. 2656.6. What is the difference between the PFC emissions (in thousand metric tons of CO2 equivalent) of 2000 and PFC emissions (in thousand metric tons of CO2 equivalent) of 2005 in Canada?
Your answer should be compact. 871.9. What is the difference between the PFC emissions (in thousand metric tons of CO2 equivalent) of 2000 and PFC emissions (in thousand metric tons of CO2 equivalent) of 2008 in Canada?
Your answer should be compact. 1166.2. What is the difference between the PFC emissions (in thousand metric tons of CO2 equivalent) in 2005 and PFC emissions (in thousand metric tons of CO2 equivalent) in 2008 in Canada?
Your answer should be very brief. 294.3. What is the difference between the PFC emissions (in thousand metric tons of CO2 equivalent) in 1990 and PFC emissions (in thousand metric tons of CO2 equivalent) in 2000 in China?
Your answer should be very brief. -3359.9. What is the difference between the PFC emissions (in thousand metric tons of CO2 equivalent) of 1990 and PFC emissions (in thousand metric tons of CO2 equivalent) of 2005 in China?
Your answer should be compact. -5888.3. What is the difference between the PFC emissions (in thousand metric tons of CO2 equivalent) of 1990 and PFC emissions (in thousand metric tons of CO2 equivalent) of 2008 in China?
Offer a terse response. -8826.1. What is the difference between the PFC emissions (in thousand metric tons of CO2 equivalent) of 2000 and PFC emissions (in thousand metric tons of CO2 equivalent) of 2005 in China?
Provide a short and direct response. -2528.4. What is the difference between the PFC emissions (in thousand metric tons of CO2 equivalent) of 2000 and PFC emissions (in thousand metric tons of CO2 equivalent) of 2008 in China?
Your response must be concise. -5466.2. What is the difference between the PFC emissions (in thousand metric tons of CO2 equivalent) of 2005 and PFC emissions (in thousand metric tons of CO2 equivalent) of 2008 in China?
Give a very brief answer. -2937.8. What is the ratio of the PFC emissions (in thousand metric tons of CO2 equivalent) of 1990 in Bosnia and Herzegovina to that in Brazil?
Your response must be concise. 0.12. What is the ratio of the PFC emissions (in thousand metric tons of CO2 equivalent) of 2000 in Bosnia and Herzegovina to that in Brazil?
Provide a succinct answer. 0.08. What is the ratio of the PFC emissions (in thousand metric tons of CO2 equivalent) of 2005 in Bosnia and Herzegovina to that in Brazil?
Make the answer very short. 0.03. What is the ratio of the PFC emissions (in thousand metric tons of CO2 equivalent) of 2008 in Bosnia and Herzegovina to that in Brazil?
Offer a very short reply. 0.02. What is the ratio of the PFC emissions (in thousand metric tons of CO2 equivalent) of 1990 in Bosnia and Herzegovina to that in Bulgaria?
Your answer should be compact. 280.32. What is the ratio of the PFC emissions (in thousand metric tons of CO2 equivalent) of 2000 in Bosnia and Herzegovina to that in Bulgaria?
Provide a succinct answer. 17.27. What is the ratio of the PFC emissions (in thousand metric tons of CO2 equivalent) of 2005 in Bosnia and Herzegovina to that in Bulgaria?
Give a very brief answer. 7.81. What is the ratio of the PFC emissions (in thousand metric tons of CO2 equivalent) in 2008 in Bosnia and Herzegovina to that in Bulgaria?
Your response must be concise. 7.45. What is the ratio of the PFC emissions (in thousand metric tons of CO2 equivalent) of 1990 in Bosnia and Herzegovina to that in Cameroon?
Make the answer very short. 0.66. What is the ratio of the PFC emissions (in thousand metric tons of CO2 equivalent) of 2000 in Bosnia and Herzegovina to that in Cameroon?
Offer a very short reply. 0.64. What is the ratio of the PFC emissions (in thousand metric tons of CO2 equivalent) in 2005 in Bosnia and Herzegovina to that in Cameroon?
Ensure brevity in your answer.  0.35. What is the ratio of the PFC emissions (in thousand metric tons of CO2 equivalent) in 2008 in Bosnia and Herzegovina to that in Cameroon?
Your answer should be compact. 0.32. What is the ratio of the PFC emissions (in thousand metric tons of CO2 equivalent) in 1990 in Bosnia and Herzegovina to that in Canada?
Make the answer very short. 0.07. What is the ratio of the PFC emissions (in thousand metric tons of CO2 equivalent) of 2000 in Bosnia and Herzegovina to that in Canada?
Your answer should be compact. 0.05. What is the ratio of the PFC emissions (in thousand metric tons of CO2 equivalent) in 2005 in Bosnia and Herzegovina to that in Canada?
Provide a short and direct response. 0.02. What is the ratio of the PFC emissions (in thousand metric tons of CO2 equivalent) of 2008 in Bosnia and Herzegovina to that in Canada?
Make the answer very short. 0.02. What is the ratio of the PFC emissions (in thousand metric tons of CO2 equivalent) in 1990 in Bosnia and Herzegovina to that in China?
Your response must be concise. 0.13. What is the ratio of the PFC emissions (in thousand metric tons of CO2 equivalent) in 2000 in Bosnia and Herzegovina to that in China?
Offer a very short reply. 0.04. What is the ratio of the PFC emissions (in thousand metric tons of CO2 equivalent) in 2005 in Bosnia and Herzegovina to that in China?
Your answer should be very brief. 0.01. What is the ratio of the PFC emissions (in thousand metric tons of CO2 equivalent) in 1990 in Brazil to that in Bulgaria?
Your response must be concise. 2253.68. What is the ratio of the PFC emissions (in thousand metric tons of CO2 equivalent) in 2000 in Brazil to that in Bulgaria?
Give a very brief answer. 215.66. What is the ratio of the PFC emissions (in thousand metric tons of CO2 equivalent) in 2005 in Brazil to that in Bulgaria?
Your answer should be very brief. 303.9. What is the ratio of the PFC emissions (in thousand metric tons of CO2 equivalent) of 2008 in Brazil to that in Bulgaria?
Keep it short and to the point. 341.86. What is the ratio of the PFC emissions (in thousand metric tons of CO2 equivalent) in 1990 in Brazil to that in Cameroon?
Keep it short and to the point. 5.32. What is the ratio of the PFC emissions (in thousand metric tons of CO2 equivalent) in 2000 in Brazil to that in Cameroon?
Keep it short and to the point. 8. What is the ratio of the PFC emissions (in thousand metric tons of CO2 equivalent) of 2005 in Brazil to that in Cameroon?
Provide a short and direct response. 13.47. What is the ratio of the PFC emissions (in thousand metric tons of CO2 equivalent) in 2008 in Brazil to that in Cameroon?
Your answer should be compact. 14.74. What is the ratio of the PFC emissions (in thousand metric tons of CO2 equivalent) in 1990 in Brazil to that in Canada?
Provide a short and direct response. 0.58. What is the ratio of the PFC emissions (in thousand metric tons of CO2 equivalent) in 2000 in Brazil to that in Canada?
Your answer should be very brief. 0.58. What is the ratio of the PFC emissions (in thousand metric tons of CO2 equivalent) in 2005 in Brazil to that in Canada?
Make the answer very short. 0.9. What is the ratio of the PFC emissions (in thousand metric tons of CO2 equivalent) in 2008 in Brazil to that in Canada?
Ensure brevity in your answer.  1.05. What is the ratio of the PFC emissions (in thousand metric tons of CO2 equivalent) of 1990 in Brazil to that in China?
Offer a terse response. 1.06. What is the ratio of the PFC emissions (in thousand metric tons of CO2 equivalent) in 2000 in Brazil to that in China?
Keep it short and to the point. 0.51. What is the ratio of the PFC emissions (in thousand metric tons of CO2 equivalent) of 2005 in Brazil to that in China?
Make the answer very short. 0.53. What is the ratio of the PFC emissions (in thousand metric tons of CO2 equivalent) in 2008 in Brazil to that in China?
Ensure brevity in your answer.  0.46. What is the ratio of the PFC emissions (in thousand metric tons of CO2 equivalent) in 1990 in Bulgaria to that in Cameroon?
Ensure brevity in your answer.  0. What is the ratio of the PFC emissions (in thousand metric tons of CO2 equivalent) of 2000 in Bulgaria to that in Cameroon?
Your response must be concise. 0.04. What is the ratio of the PFC emissions (in thousand metric tons of CO2 equivalent) in 2005 in Bulgaria to that in Cameroon?
Keep it short and to the point. 0.04. What is the ratio of the PFC emissions (in thousand metric tons of CO2 equivalent) of 2008 in Bulgaria to that in Cameroon?
Provide a succinct answer. 0.04. What is the ratio of the PFC emissions (in thousand metric tons of CO2 equivalent) in 2000 in Bulgaria to that in Canada?
Offer a very short reply. 0. What is the ratio of the PFC emissions (in thousand metric tons of CO2 equivalent) in 2005 in Bulgaria to that in Canada?
Provide a succinct answer. 0. What is the ratio of the PFC emissions (in thousand metric tons of CO2 equivalent) of 2008 in Bulgaria to that in Canada?
Your response must be concise. 0. What is the ratio of the PFC emissions (in thousand metric tons of CO2 equivalent) in 2000 in Bulgaria to that in China?
Give a very brief answer. 0. What is the ratio of the PFC emissions (in thousand metric tons of CO2 equivalent) in 2005 in Bulgaria to that in China?
Offer a terse response. 0. What is the ratio of the PFC emissions (in thousand metric tons of CO2 equivalent) in 2008 in Bulgaria to that in China?
Offer a very short reply. 0. What is the ratio of the PFC emissions (in thousand metric tons of CO2 equivalent) of 1990 in Cameroon to that in Canada?
Your answer should be very brief. 0.11. What is the ratio of the PFC emissions (in thousand metric tons of CO2 equivalent) in 2000 in Cameroon to that in Canada?
Offer a very short reply. 0.07. What is the ratio of the PFC emissions (in thousand metric tons of CO2 equivalent) in 2005 in Cameroon to that in Canada?
Your answer should be compact. 0.07. What is the ratio of the PFC emissions (in thousand metric tons of CO2 equivalent) in 2008 in Cameroon to that in Canada?
Ensure brevity in your answer.  0.07. What is the ratio of the PFC emissions (in thousand metric tons of CO2 equivalent) of 1990 in Cameroon to that in China?
Ensure brevity in your answer.  0.2. What is the ratio of the PFC emissions (in thousand metric tons of CO2 equivalent) in 2000 in Cameroon to that in China?
Provide a succinct answer. 0.06. What is the ratio of the PFC emissions (in thousand metric tons of CO2 equivalent) of 2005 in Cameroon to that in China?
Your answer should be very brief. 0.04. What is the ratio of the PFC emissions (in thousand metric tons of CO2 equivalent) in 2008 in Cameroon to that in China?
Keep it short and to the point. 0.03. What is the ratio of the PFC emissions (in thousand metric tons of CO2 equivalent) in 1990 in Canada to that in China?
Keep it short and to the point. 1.84. What is the ratio of the PFC emissions (in thousand metric tons of CO2 equivalent) of 2000 in Canada to that in China?
Offer a very short reply. 0.88. What is the ratio of the PFC emissions (in thousand metric tons of CO2 equivalent) of 2005 in Canada to that in China?
Give a very brief answer. 0.59. What is the ratio of the PFC emissions (in thousand metric tons of CO2 equivalent) in 2008 in Canada to that in China?
Provide a succinct answer. 0.44. What is the difference between the highest and the second highest PFC emissions (in thousand metric tons of CO2 equivalent) in 1990?
Ensure brevity in your answer.  3642.2. What is the difference between the highest and the second highest PFC emissions (in thousand metric tons of CO2 equivalent) in 2000?
Ensure brevity in your answer.  924.5. What is the difference between the highest and the second highest PFC emissions (in thousand metric tons of CO2 equivalent) in 2005?
Your response must be concise. 4324.8. What is the difference between the highest and the second highest PFC emissions (in thousand metric tons of CO2 equivalent) of 2008?
Your answer should be very brief. 7278.8. What is the difference between the highest and the lowest PFC emissions (in thousand metric tons of CO2 equivalent) in 1990?
Ensure brevity in your answer.  8598.1. What is the difference between the highest and the lowest PFC emissions (in thousand metric tons of CO2 equivalent) in 2000?
Your answer should be compact. 8015.3. What is the difference between the highest and the lowest PFC emissions (in thousand metric tons of CO2 equivalent) in 2005?
Your response must be concise. 1.05e+04. What is the difference between the highest and the lowest PFC emissions (in thousand metric tons of CO2 equivalent) in 2008?
Provide a succinct answer. 1.35e+04. 